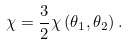<formula> <loc_0><loc_0><loc_500><loc_500>\chi = \frac { 3 } { 2 } \chi \left ( \theta _ { 1 } , \theta _ { 2 } \right ) .</formula> 